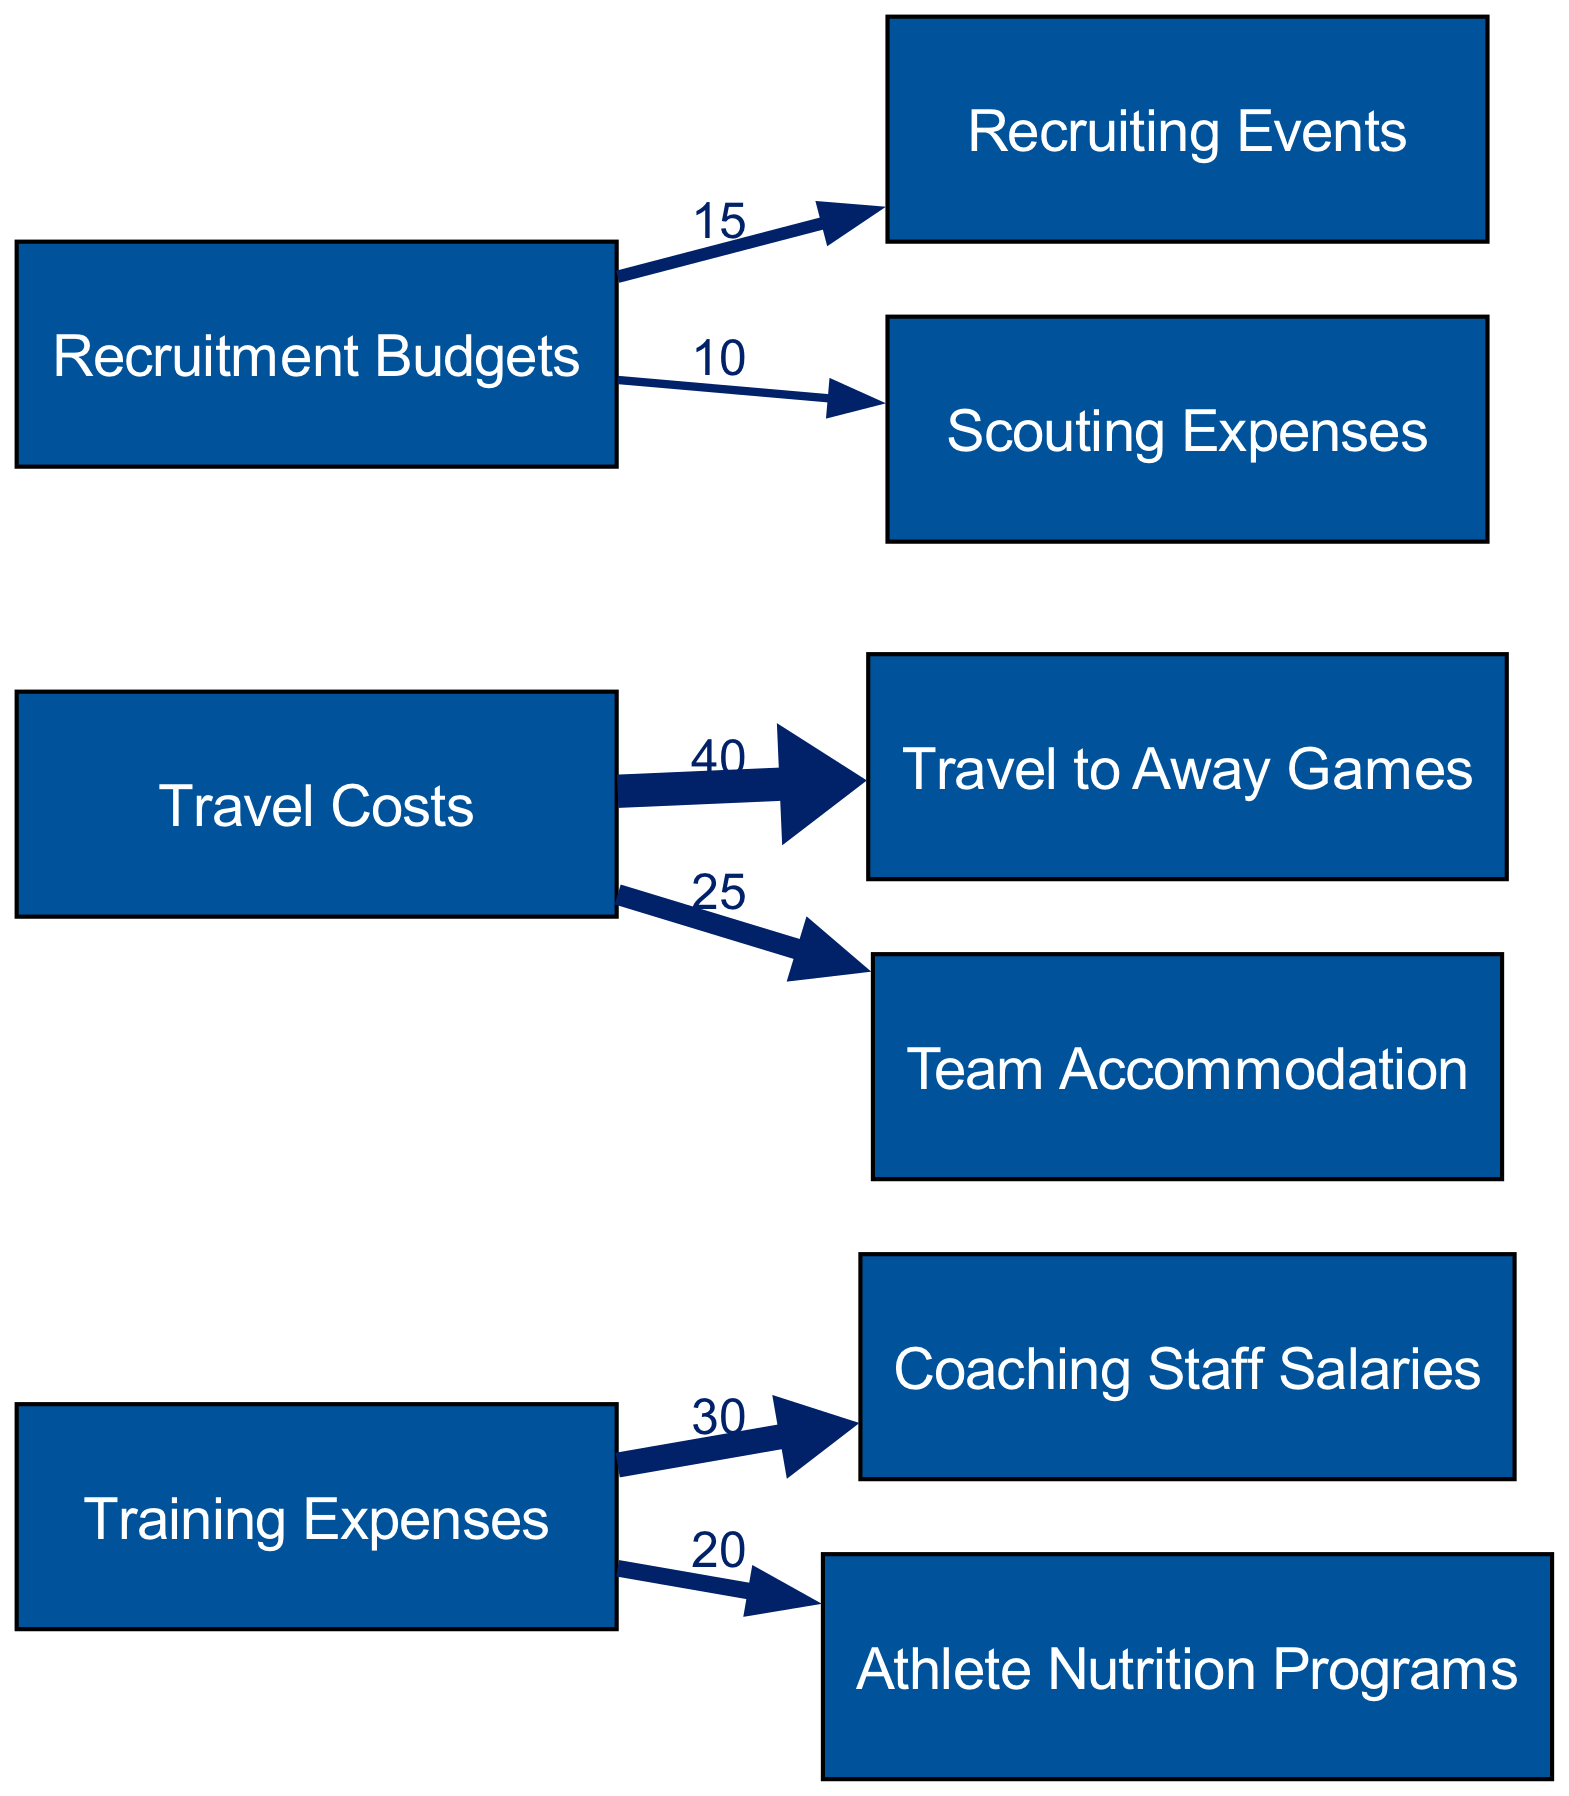What is the total value of training expenses directed towards coaching staff salaries? The diagram indicates that the value of the link from Training Expenses to Coaching Staff Salaries is 30. So, the total value directed towards coaching staff salaries is simply this number.
Answer: 30 What is the total value of recruitment budgets allocated to recruiting events and scouting expenses? To find this total, I need to add the values of the links from Recruitment Budgets: 15 for Recruiting Events and 10 for Scouting Expenses. Summing these gives 15 + 10 = 25.
Answer: 25 How many nodes are represented in the diagram? The diagram displays 9 nodes in total, which can be counted directly from the list of nodes provided in the data section.
Answer: 9 What is the value of travel costs associated with team accommodation? Looking at the diagram, the link from Travel Costs to Team Accommodation has a value of 25. This directly indicates the amount allocated for team accommodation under travel costs.
Answer: 25 Which category has the highest total allocation? To determine this, I compare all outgoing links: Training Expenses (30 + 20 = 50), Travel Costs (40 + 25 = 65), and Recruitment Budgets (15 + 10 = 25). Travel Costs, with a total of 65, is the highest allocation.
Answer: Travel Costs What is the total value directed from travel costs? The total value can be calculated by summing the outbound links from Travel Costs: 40 (Travel to Away Games) + 25 (Team Accommodation) = 65. This gives the complete total directed from travel costs.
Answer: 65 What is the relationship between training expenses and athlete nutrition programs? The diagram shows a direct link from Training Expenses to Athlete Nutrition Programs with a value of 20, indicating that part of the training expenses is allocated to this program.
Answer: 20 What is the combined value of travel to away games and team accommodation? To find this, I add the two values from the Travel Costs links: 40 (Travel to Away Games) + 25 (Team Accommodation) = 65. This sum provides the total value for both travel expenses.
Answer: 65 How does Recruitment Budgets distribute into recruiting events and scouting expenses? The diagram shows two outgoing links from Recruitment Budgets: one to Recruiting Events with a value of 15 and another to Scouting Expenses with a value of 10. This distribution indicates how the overall budget is split between these two areas.
Answer: 15 and 10 